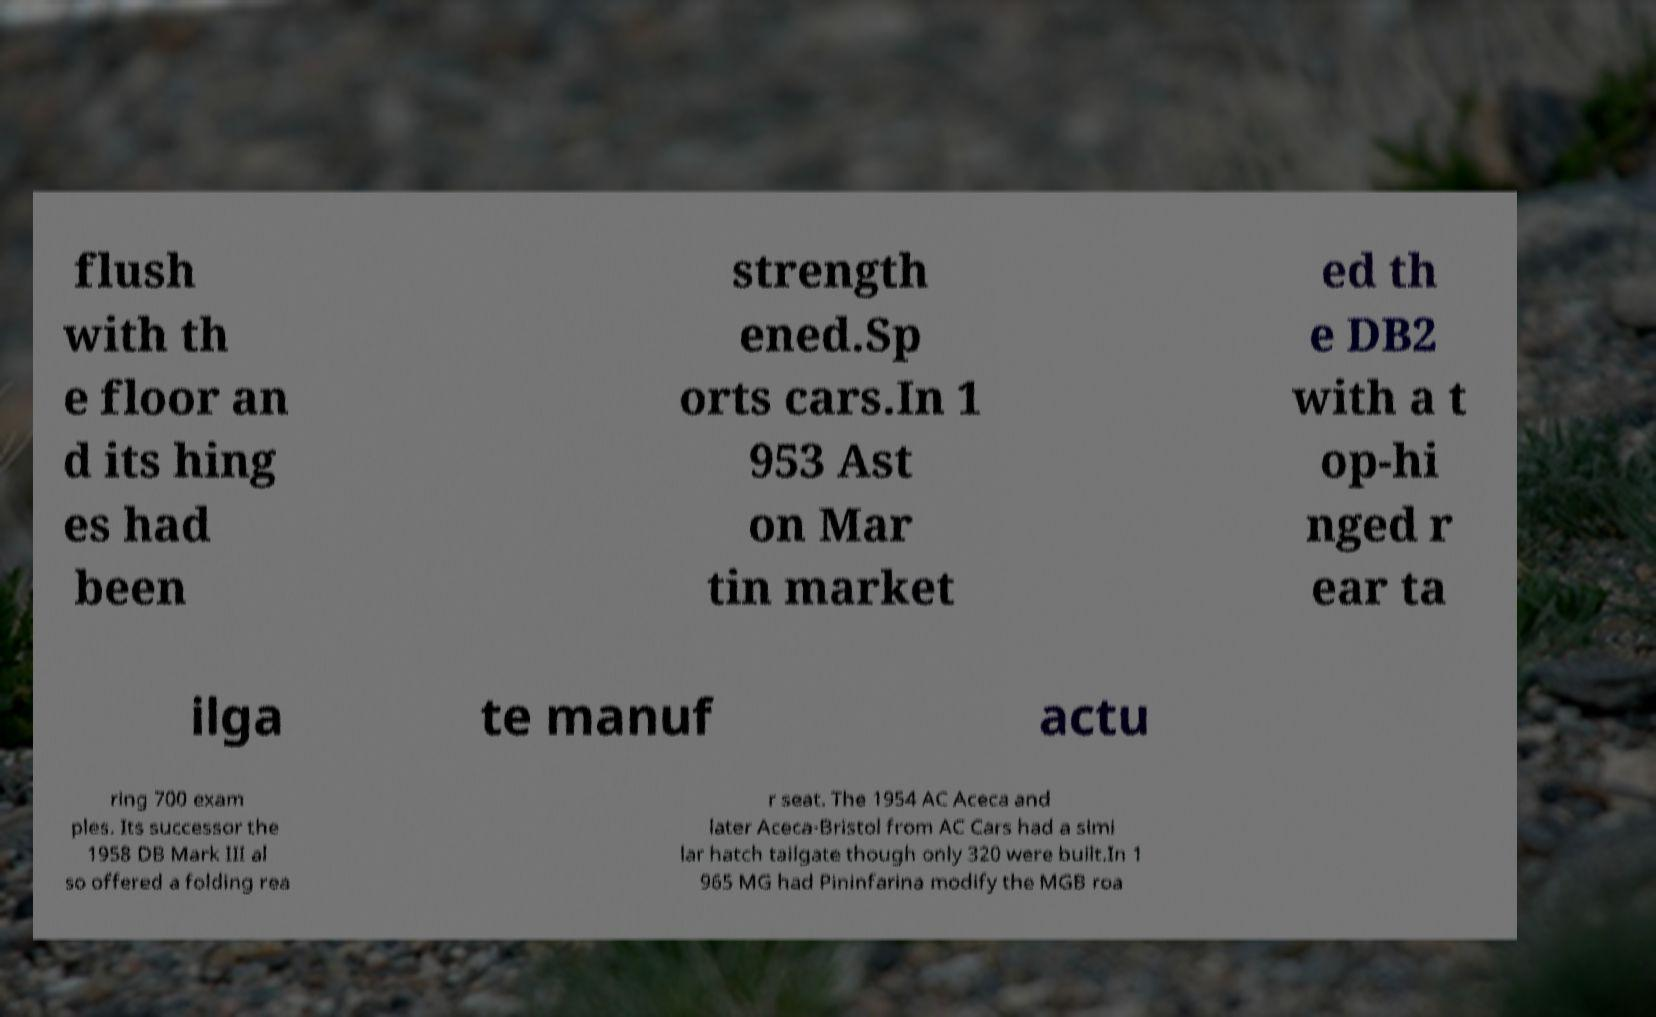Can you read and provide the text displayed in the image?This photo seems to have some interesting text. Can you extract and type it out for me? flush with th e floor an d its hing es had been strength ened.Sp orts cars.In 1 953 Ast on Mar tin market ed th e DB2 with a t op-hi nged r ear ta ilga te manuf actu ring 700 exam ples. Its successor the 1958 DB Mark III al so offered a folding rea r seat. The 1954 AC Aceca and later Aceca-Bristol from AC Cars had a simi lar hatch tailgate though only 320 were built.In 1 965 MG had Pininfarina modify the MGB roa 